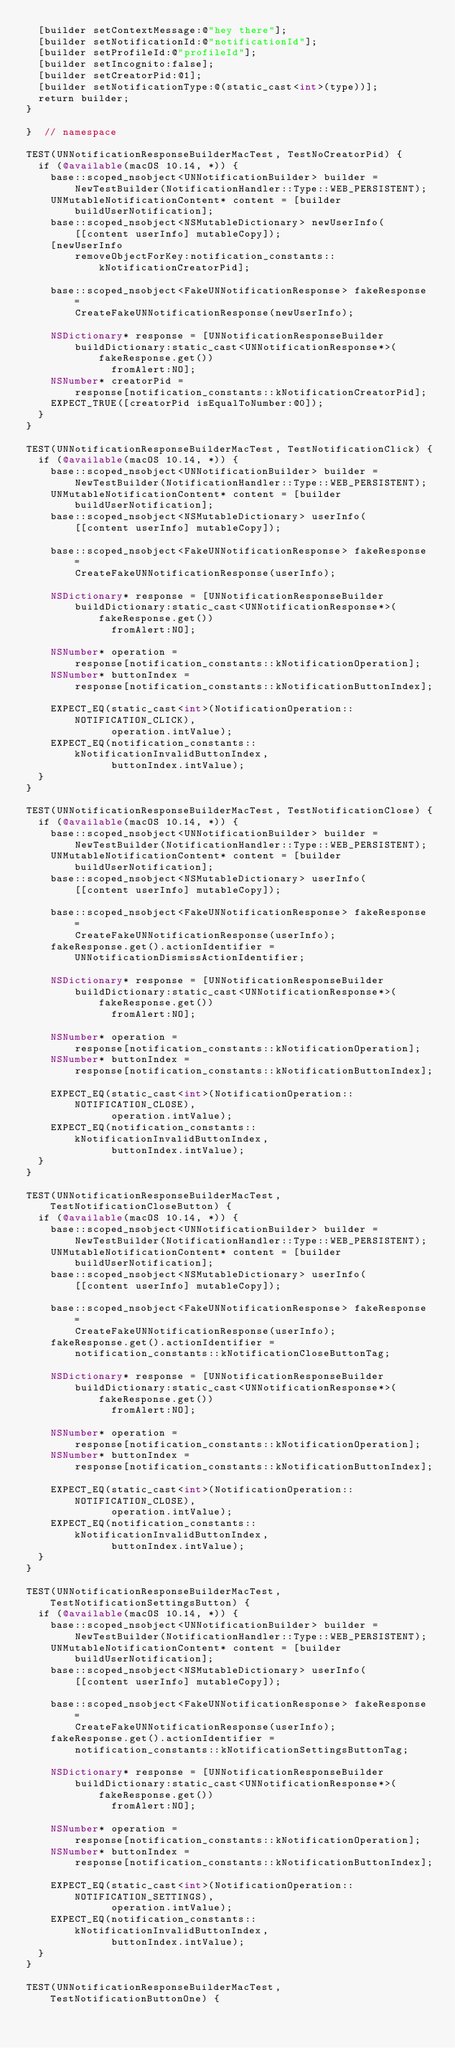Convert code to text. <code><loc_0><loc_0><loc_500><loc_500><_ObjectiveC_>  [builder setContextMessage:@"hey there"];
  [builder setNotificationId:@"notificationId"];
  [builder setProfileId:@"profileId"];
  [builder setIncognito:false];
  [builder setCreatorPid:@1];
  [builder setNotificationType:@(static_cast<int>(type))];
  return builder;
}

}  // namespace

TEST(UNNotificationResponseBuilderMacTest, TestNoCreatorPid) {
  if (@available(macOS 10.14, *)) {
    base::scoped_nsobject<UNNotificationBuilder> builder =
        NewTestBuilder(NotificationHandler::Type::WEB_PERSISTENT);
    UNMutableNotificationContent* content = [builder buildUserNotification];
    base::scoped_nsobject<NSMutableDictionary> newUserInfo(
        [[content userInfo] mutableCopy]);
    [newUserInfo
        removeObjectForKey:notification_constants::kNotificationCreatorPid];

    base::scoped_nsobject<FakeUNNotificationResponse> fakeResponse =
        CreateFakeUNNotificationResponse(newUserInfo);

    NSDictionary* response = [UNNotificationResponseBuilder
        buildDictionary:static_cast<UNNotificationResponse*>(fakeResponse.get())
              fromAlert:NO];
    NSNumber* creatorPid =
        response[notification_constants::kNotificationCreatorPid];
    EXPECT_TRUE([creatorPid isEqualToNumber:@0]);
  }
}

TEST(UNNotificationResponseBuilderMacTest, TestNotificationClick) {
  if (@available(macOS 10.14, *)) {
    base::scoped_nsobject<UNNotificationBuilder> builder =
        NewTestBuilder(NotificationHandler::Type::WEB_PERSISTENT);
    UNMutableNotificationContent* content = [builder buildUserNotification];
    base::scoped_nsobject<NSMutableDictionary> userInfo(
        [[content userInfo] mutableCopy]);

    base::scoped_nsobject<FakeUNNotificationResponse> fakeResponse =
        CreateFakeUNNotificationResponse(userInfo);

    NSDictionary* response = [UNNotificationResponseBuilder
        buildDictionary:static_cast<UNNotificationResponse*>(fakeResponse.get())
              fromAlert:NO];

    NSNumber* operation =
        response[notification_constants::kNotificationOperation];
    NSNumber* buttonIndex =
        response[notification_constants::kNotificationButtonIndex];

    EXPECT_EQ(static_cast<int>(NotificationOperation::NOTIFICATION_CLICK),
              operation.intValue);
    EXPECT_EQ(notification_constants::kNotificationInvalidButtonIndex,
              buttonIndex.intValue);
  }
}

TEST(UNNotificationResponseBuilderMacTest, TestNotificationClose) {
  if (@available(macOS 10.14, *)) {
    base::scoped_nsobject<UNNotificationBuilder> builder =
        NewTestBuilder(NotificationHandler::Type::WEB_PERSISTENT);
    UNMutableNotificationContent* content = [builder buildUserNotification];
    base::scoped_nsobject<NSMutableDictionary> userInfo(
        [[content userInfo] mutableCopy]);

    base::scoped_nsobject<FakeUNNotificationResponse> fakeResponse =
        CreateFakeUNNotificationResponse(userInfo);
    fakeResponse.get().actionIdentifier = UNNotificationDismissActionIdentifier;

    NSDictionary* response = [UNNotificationResponseBuilder
        buildDictionary:static_cast<UNNotificationResponse*>(fakeResponse.get())
              fromAlert:NO];

    NSNumber* operation =
        response[notification_constants::kNotificationOperation];
    NSNumber* buttonIndex =
        response[notification_constants::kNotificationButtonIndex];

    EXPECT_EQ(static_cast<int>(NotificationOperation::NOTIFICATION_CLOSE),
              operation.intValue);
    EXPECT_EQ(notification_constants::kNotificationInvalidButtonIndex,
              buttonIndex.intValue);
  }
}

TEST(UNNotificationResponseBuilderMacTest, TestNotificationCloseButton) {
  if (@available(macOS 10.14, *)) {
    base::scoped_nsobject<UNNotificationBuilder> builder =
        NewTestBuilder(NotificationHandler::Type::WEB_PERSISTENT);
    UNMutableNotificationContent* content = [builder buildUserNotification];
    base::scoped_nsobject<NSMutableDictionary> userInfo(
        [[content userInfo] mutableCopy]);

    base::scoped_nsobject<FakeUNNotificationResponse> fakeResponse =
        CreateFakeUNNotificationResponse(userInfo);
    fakeResponse.get().actionIdentifier =
        notification_constants::kNotificationCloseButtonTag;

    NSDictionary* response = [UNNotificationResponseBuilder
        buildDictionary:static_cast<UNNotificationResponse*>(fakeResponse.get())
              fromAlert:NO];

    NSNumber* operation =
        response[notification_constants::kNotificationOperation];
    NSNumber* buttonIndex =
        response[notification_constants::kNotificationButtonIndex];

    EXPECT_EQ(static_cast<int>(NotificationOperation::NOTIFICATION_CLOSE),
              operation.intValue);
    EXPECT_EQ(notification_constants::kNotificationInvalidButtonIndex,
              buttonIndex.intValue);
  }
}

TEST(UNNotificationResponseBuilderMacTest, TestNotificationSettingsButton) {
  if (@available(macOS 10.14, *)) {
    base::scoped_nsobject<UNNotificationBuilder> builder =
        NewTestBuilder(NotificationHandler::Type::WEB_PERSISTENT);
    UNMutableNotificationContent* content = [builder buildUserNotification];
    base::scoped_nsobject<NSMutableDictionary> userInfo(
        [[content userInfo] mutableCopy]);

    base::scoped_nsobject<FakeUNNotificationResponse> fakeResponse =
        CreateFakeUNNotificationResponse(userInfo);
    fakeResponse.get().actionIdentifier =
        notification_constants::kNotificationSettingsButtonTag;

    NSDictionary* response = [UNNotificationResponseBuilder
        buildDictionary:static_cast<UNNotificationResponse*>(fakeResponse.get())
              fromAlert:NO];

    NSNumber* operation =
        response[notification_constants::kNotificationOperation];
    NSNumber* buttonIndex =
        response[notification_constants::kNotificationButtonIndex];

    EXPECT_EQ(static_cast<int>(NotificationOperation::NOTIFICATION_SETTINGS),
              operation.intValue);
    EXPECT_EQ(notification_constants::kNotificationInvalidButtonIndex,
              buttonIndex.intValue);
  }
}

TEST(UNNotificationResponseBuilderMacTest, TestNotificationButtonOne) {</code> 